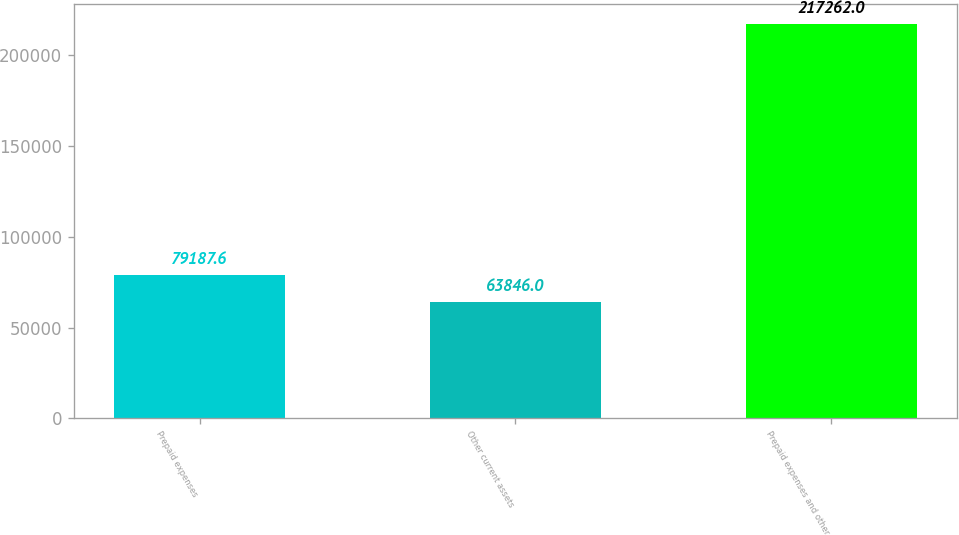Convert chart to OTSL. <chart><loc_0><loc_0><loc_500><loc_500><bar_chart><fcel>Prepaid expenses<fcel>Other current assets<fcel>Prepaid expenses and other<nl><fcel>79187.6<fcel>63846<fcel>217262<nl></chart> 